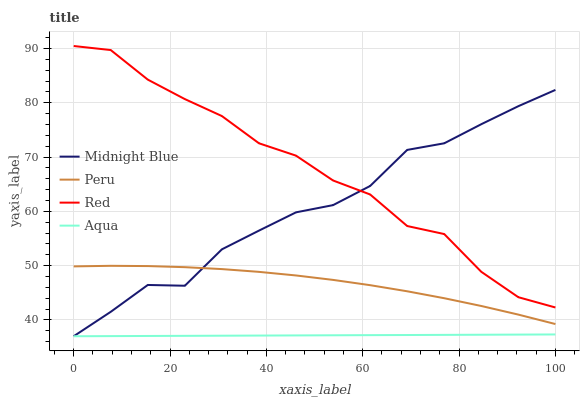Does Aqua have the minimum area under the curve?
Answer yes or no. Yes. Does Red have the maximum area under the curve?
Answer yes or no. Yes. Does Midnight Blue have the minimum area under the curve?
Answer yes or no. No. Does Midnight Blue have the maximum area under the curve?
Answer yes or no. No. Is Aqua the smoothest?
Answer yes or no. Yes. Is Red the roughest?
Answer yes or no. Yes. Is Midnight Blue the smoothest?
Answer yes or no. No. Is Midnight Blue the roughest?
Answer yes or no. No. Does Aqua have the lowest value?
Answer yes or no. Yes. Does Peru have the lowest value?
Answer yes or no. No. Does Red have the highest value?
Answer yes or no. Yes. Does Midnight Blue have the highest value?
Answer yes or no. No. Is Aqua less than Peru?
Answer yes or no. Yes. Is Red greater than Aqua?
Answer yes or no. Yes. Does Midnight Blue intersect Red?
Answer yes or no. Yes. Is Midnight Blue less than Red?
Answer yes or no. No. Is Midnight Blue greater than Red?
Answer yes or no. No. Does Aqua intersect Peru?
Answer yes or no. No. 